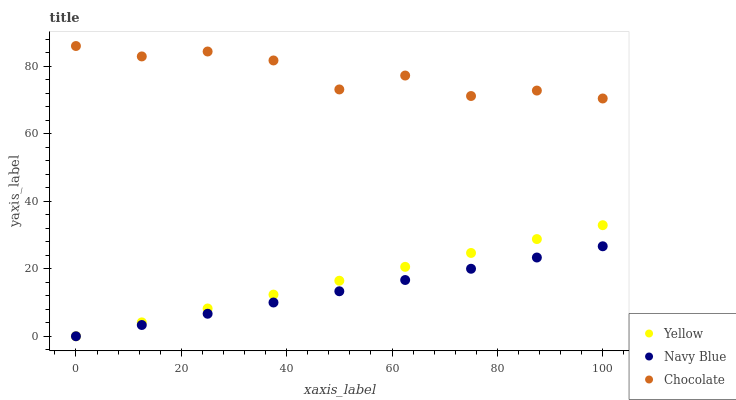Does Navy Blue have the minimum area under the curve?
Answer yes or no. Yes. Does Chocolate have the maximum area under the curve?
Answer yes or no. Yes. Does Yellow have the minimum area under the curve?
Answer yes or no. No. Does Yellow have the maximum area under the curve?
Answer yes or no. No. Is Yellow the smoothest?
Answer yes or no. Yes. Is Chocolate the roughest?
Answer yes or no. Yes. Is Chocolate the smoothest?
Answer yes or no. No. Is Yellow the roughest?
Answer yes or no. No. Does Navy Blue have the lowest value?
Answer yes or no. Yes. Does Chocolate have the lowest value?
Answer yes or no. No. Does Chocolate have the highest value?
Answer yes or no. Yes. Does Yellow have the highest value?
Answer yes or no. No. Is Yellow less than Chocolate?
Answer yes or no. Yes. Is Chocolate greater than Navy Blue?
Answer yes or no. Yes. Does Navy Blue intersect Yellow?
Answer yes or no. Yes. Is Navy Blue less than Yellow?
Answer yes or no. No. Is Navy Blue greater than Yellow?
Answer yes or no. No. Does Yellow intersect Chocolate?
Answer yes or no. No. 